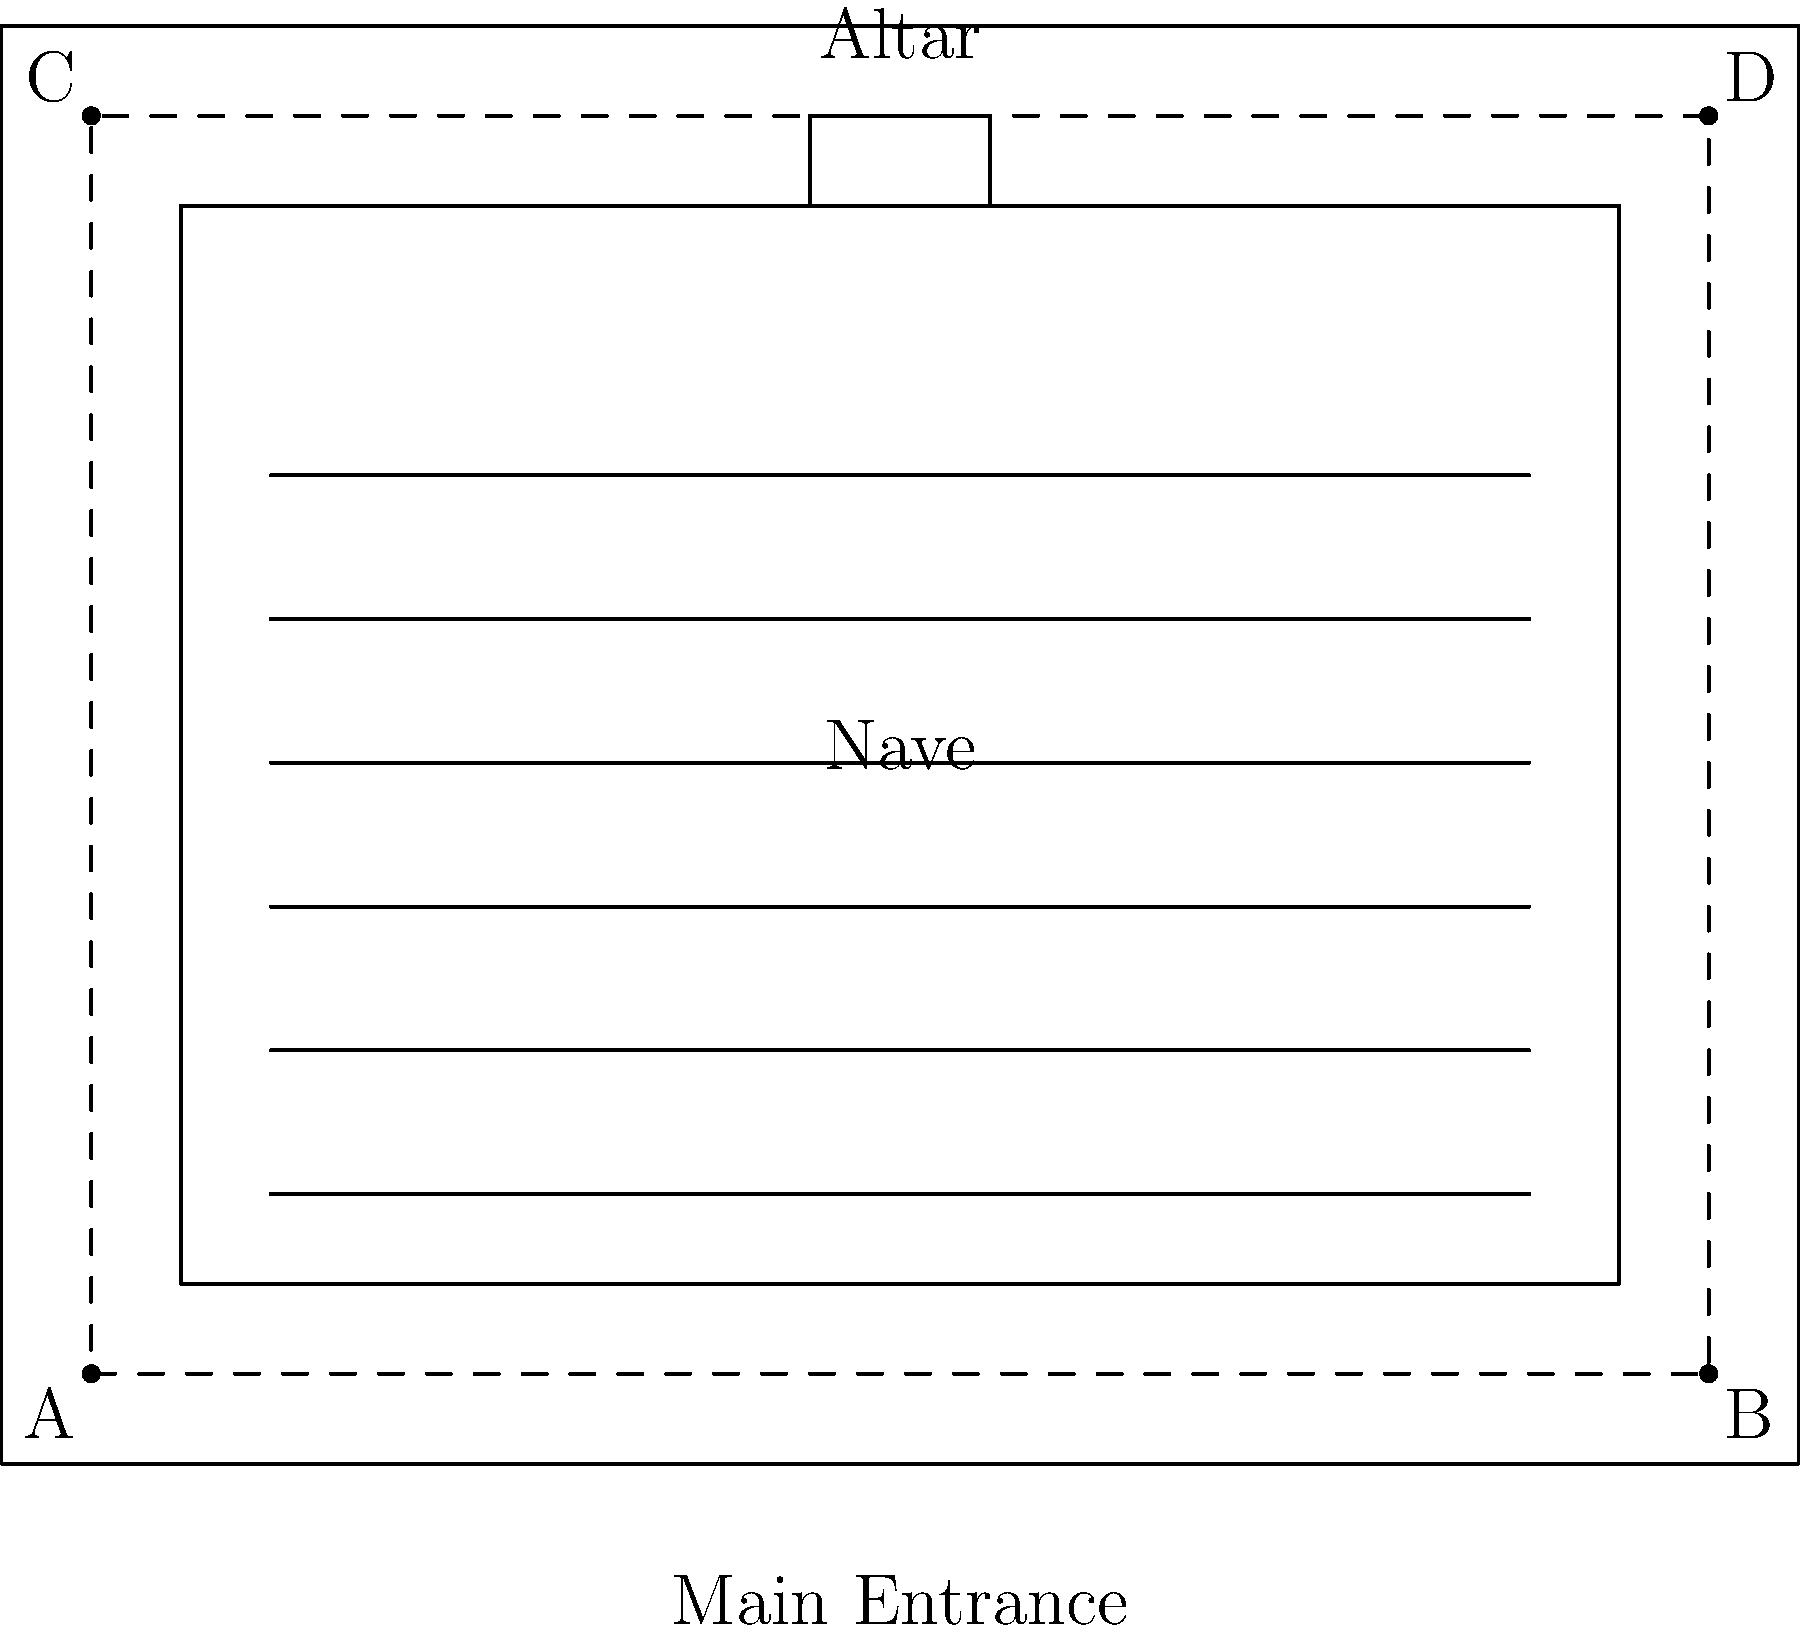In the floor plan of this 19th-century church, you can see the main electrical wiring layout represented by the dashed lines. Which path would the wiring most likely follow to minimize disruption to the congregation and preserve the aesthetic of the church interior? To answer this question, we need to consider the following factors:

1. 19th-century church architecture: Churches of this era typically had high ceilings and ornate interiors that needed to be preserved.

2. Minimal disruption: The wiring should be installed in a way that doesn't interfere with the congregation or church activities.

3. Aesthetic preservation: The wiring should be as hidden as possible to maintain the church's historical appearance.

4. Practical considerations: The wiring needs to reach all necessary areas of the church efficiently.

Given these factors:

1. The wiring would likely run along the perimeter of the church, as shown by the dashed lines connecting points A, B, C, and D.

2. This path allows for the wiring to be hidden behind baseboards, in the walls, or in the ceiling cornices, preserving the aesthetic of the church interior.

3. By following the outer walls, the installation would cause minimal disruption to the main areas of the church, such as the nave and altar.

4. This layout provides access to all corners of the church, allowing for efficient distribution of electricity to various points as needed.

5. The perimeter path also makes it easier to add new electrical points or make repairs without disturbing the main areas of worship.

Therefore, the most likely path for the electrical wiring would be along the perimeter of the church, following the dashed line from A to B to D to C and back to A.
Answer: Along the perimeter (A-B-D-C-A) 